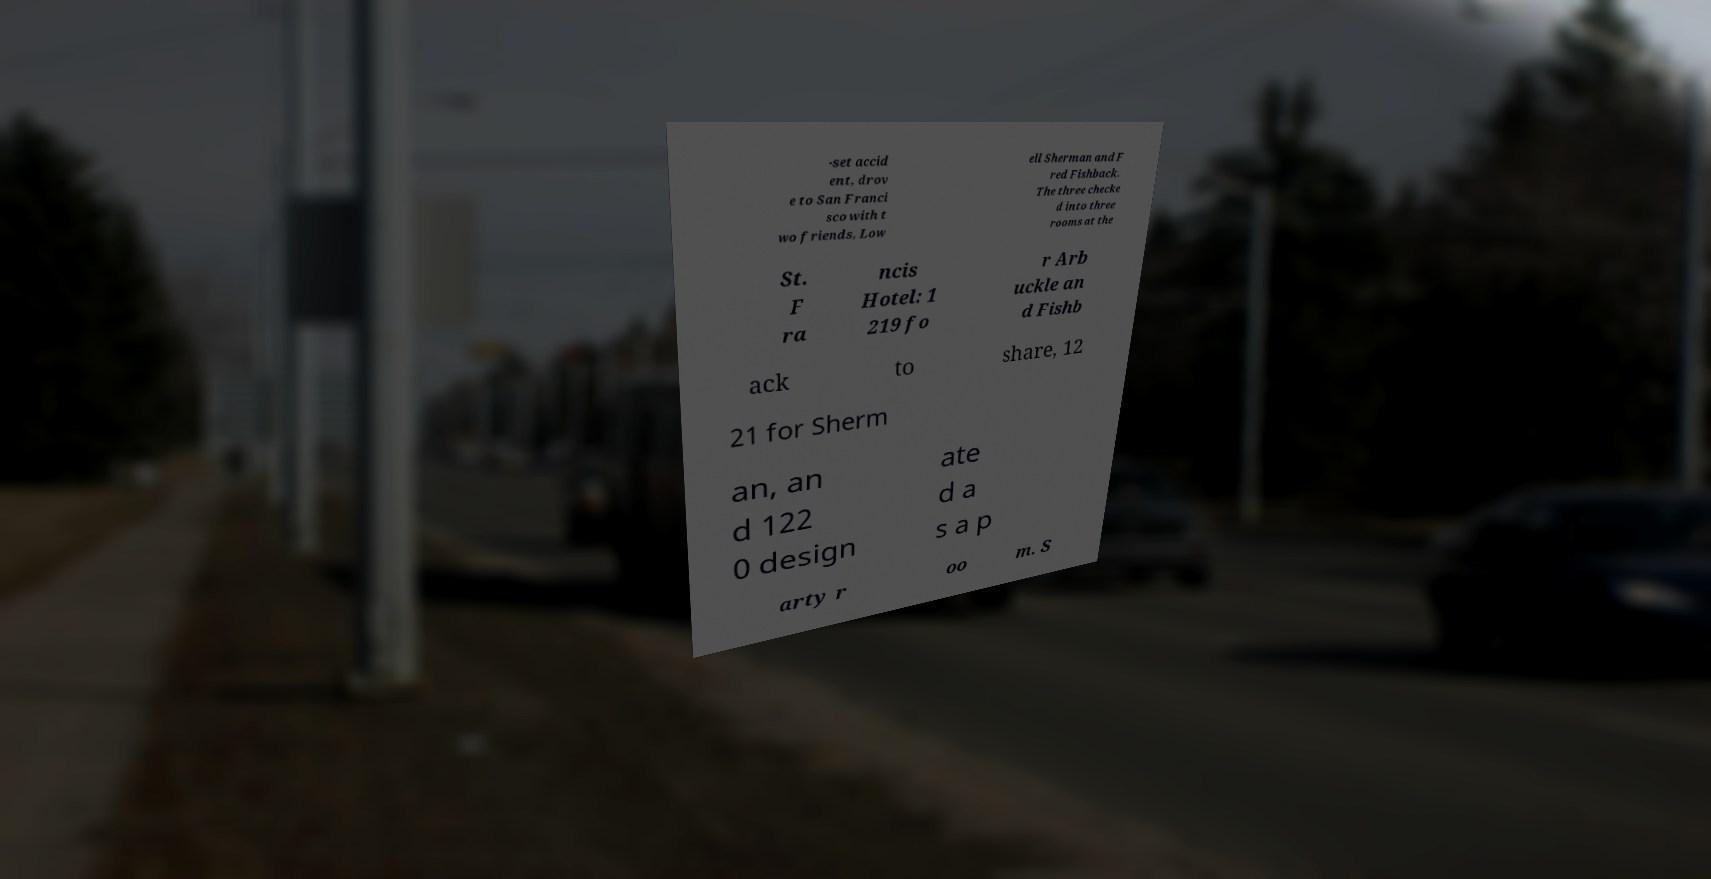Could you assist in decoding the text presented in this image and type it out clearly? -set accid ent, drov e to San Franci sco with t wo friends, Low ell Sherman and F red Fishback. The three checke d into three rooms at the St. F ra ncis Hotel: 1 219 fo r Arb uckle an d Fishb ack to share, 12 21 for Sherm an, an d 122 0 design ate d a s a p arty r oo m. S 